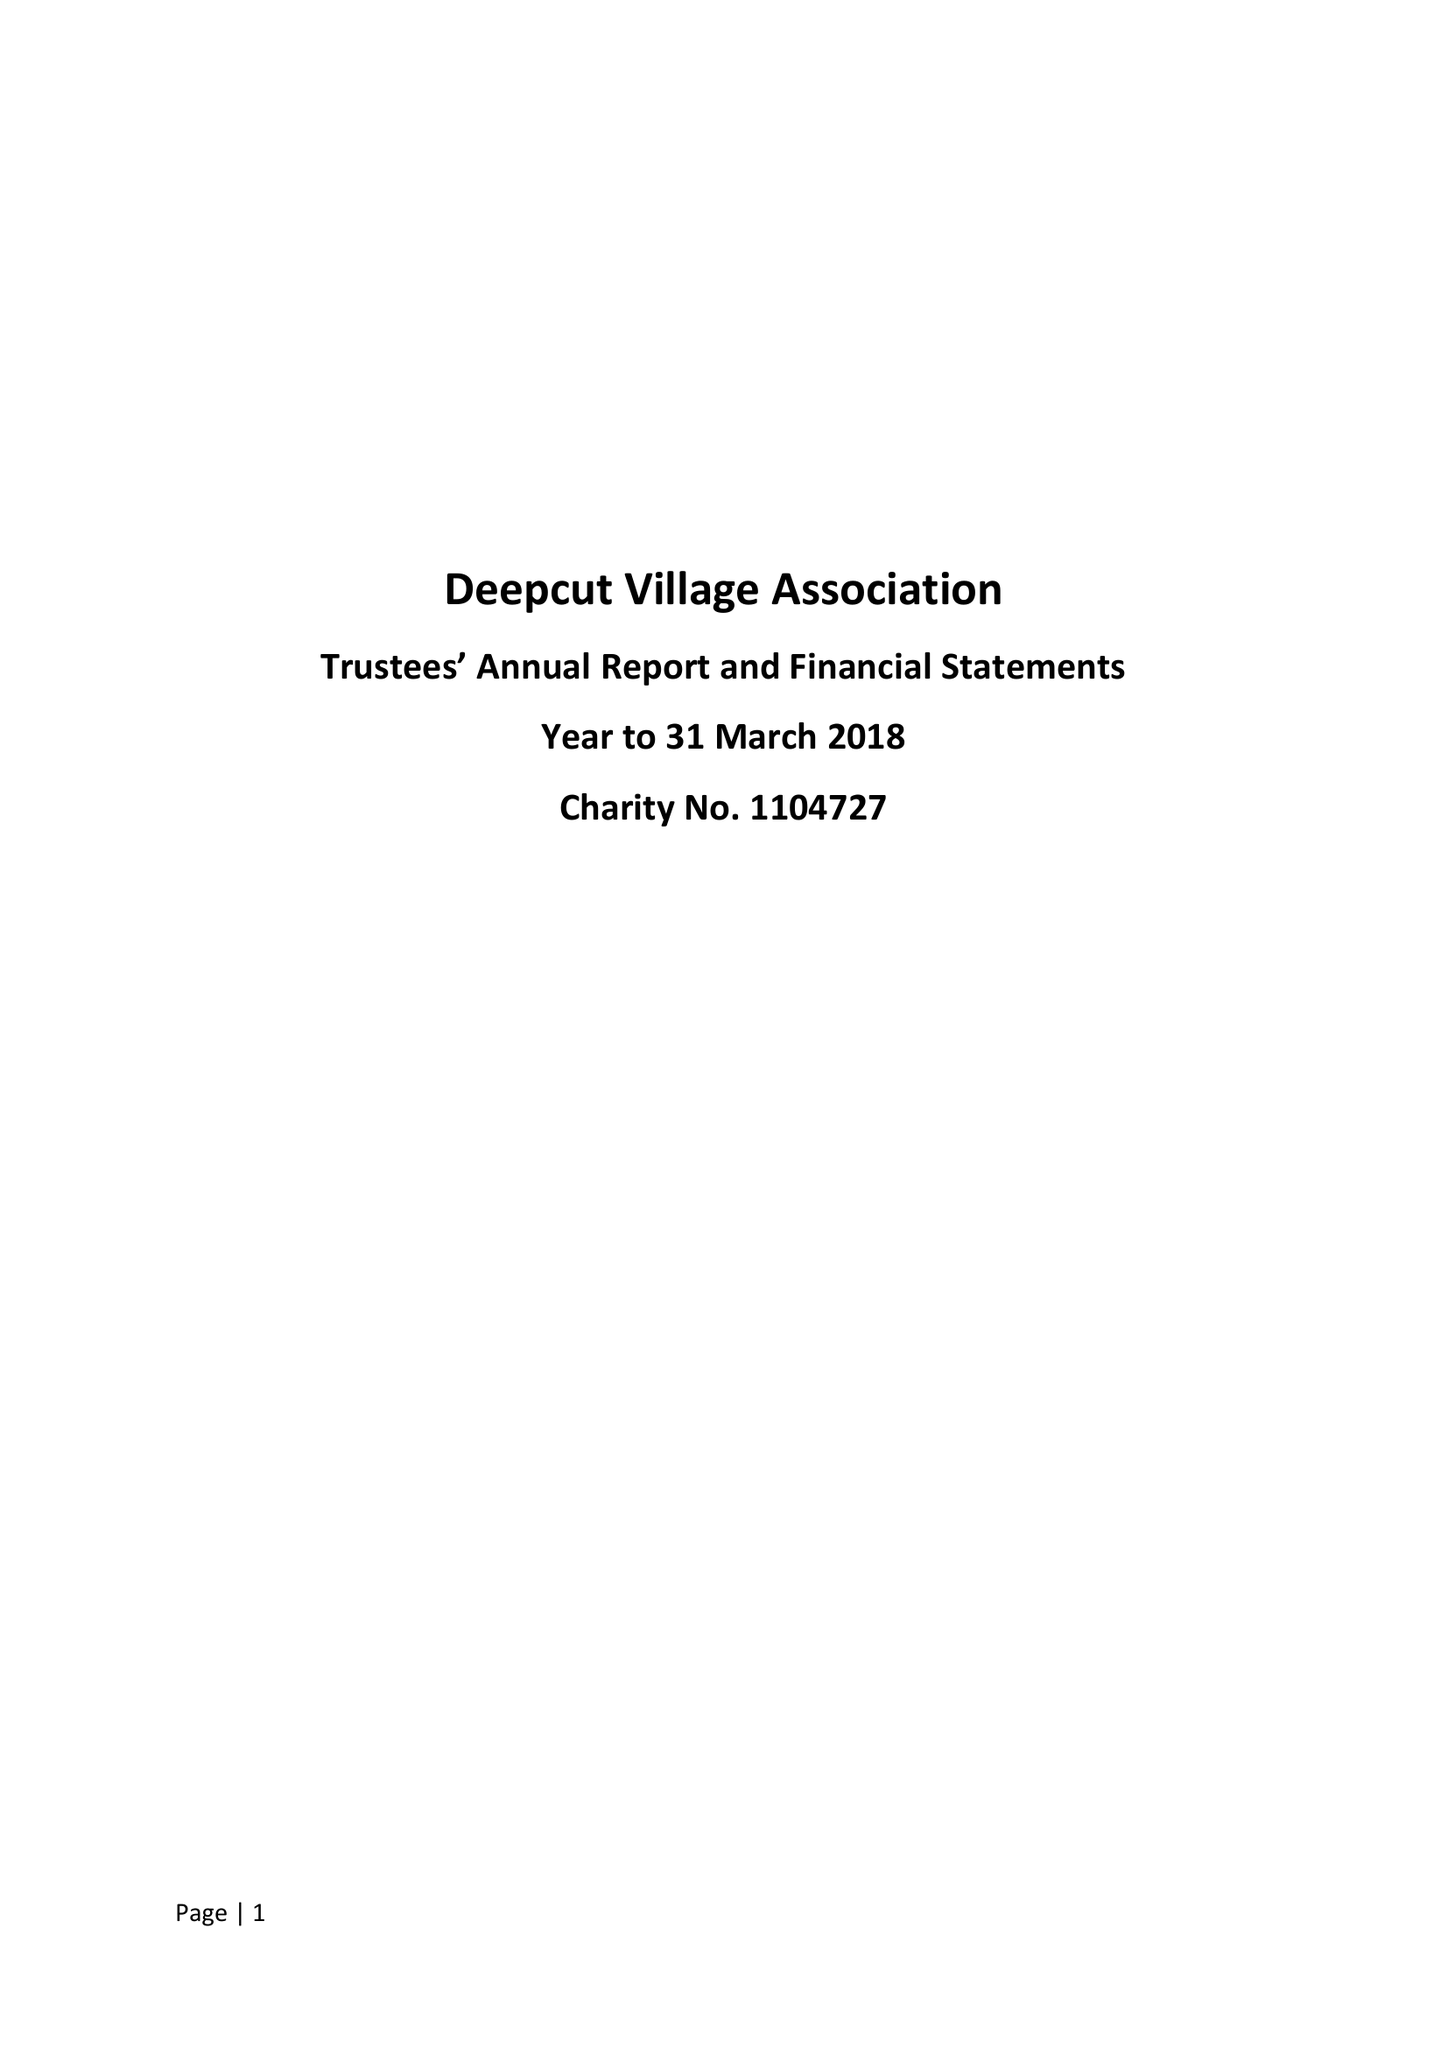What is the value for the spending_annually_in_british_pounds?
Answer the question using a single word or phrase. 57802.00 